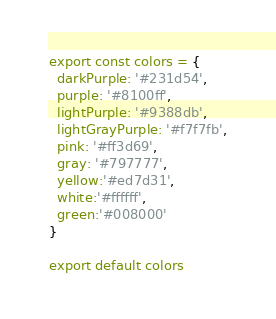Convert code to text. <code><loc_0><loc_0><loc_500><loc_500><_JavaScript_>
export const colors = {
  darkPurple: '#231d54',
  purple: '#8100ff',
  lightPurple: '#9388db',
  lightGrayPurple: '#f7f7fb',
  pink: '#ff3d69',
  gray: '#797777',
  yellow:'#ed7d31',
  white:'#ffffff',
  green:'#008000'
}

export default colors
</code> 